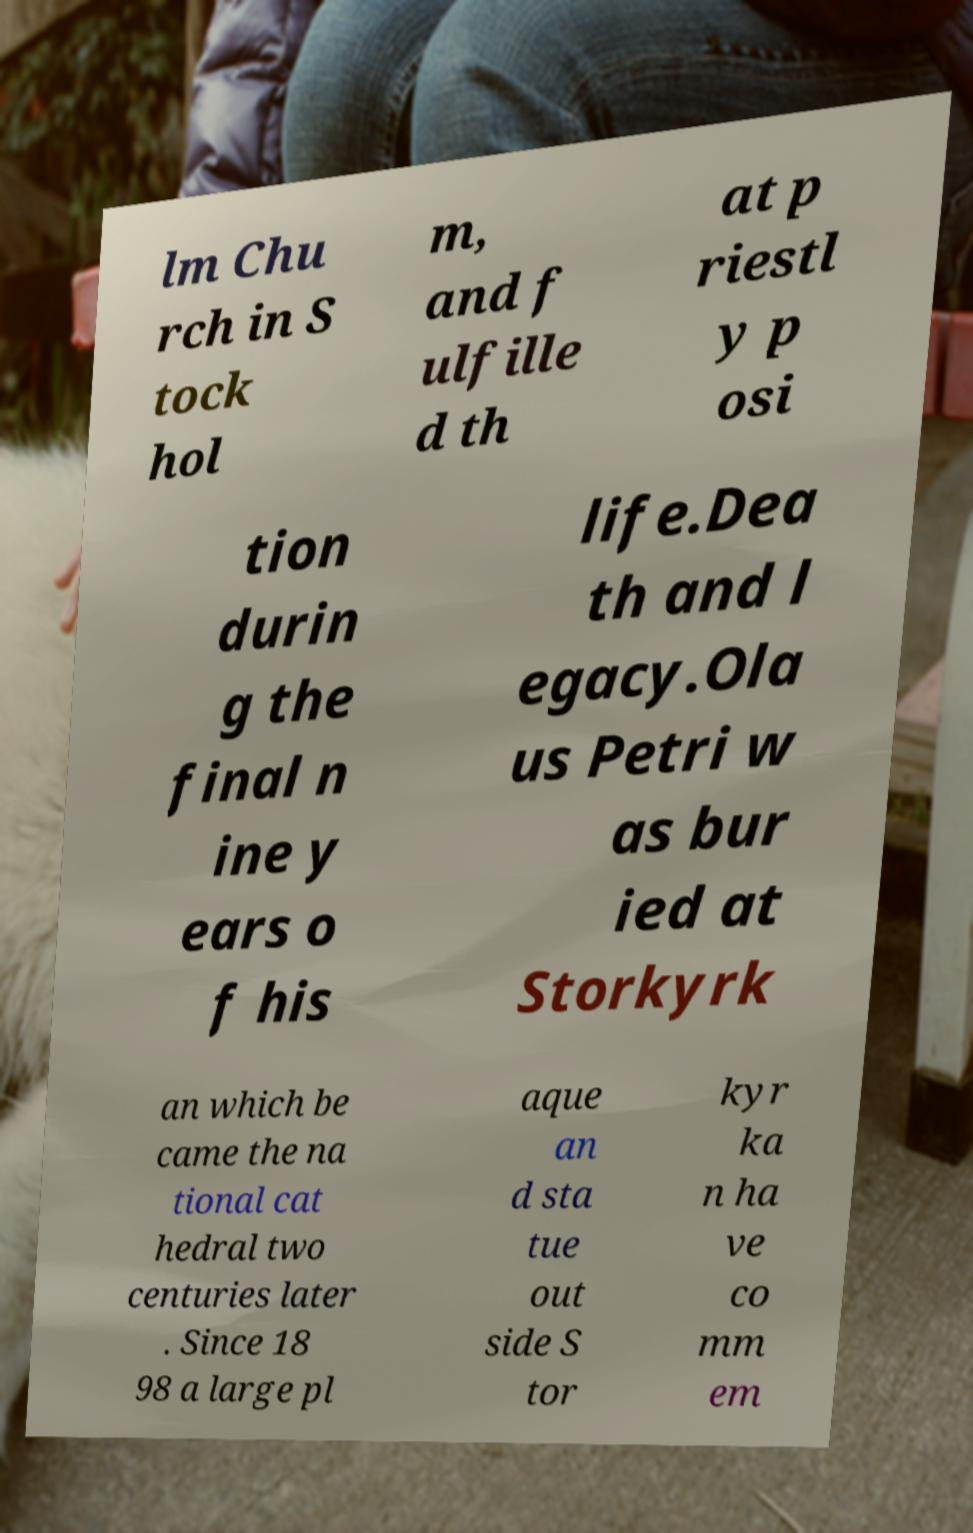For documentation purposes, I need the text within this image transcribed. Could you provide that? lm Chu rch in S tock hol m, and f ulfille d th at p riestl y p osi tion durin g the final n ine y ears o f his life.Dea th and l egacy.Ola us Petri w as bur ied at Storkyrk an which be came the na tional cat hedral two centuries later . Since 18 98 a large pl aque an d sta tue out side S tor kyr ka n ha ve co mm em 